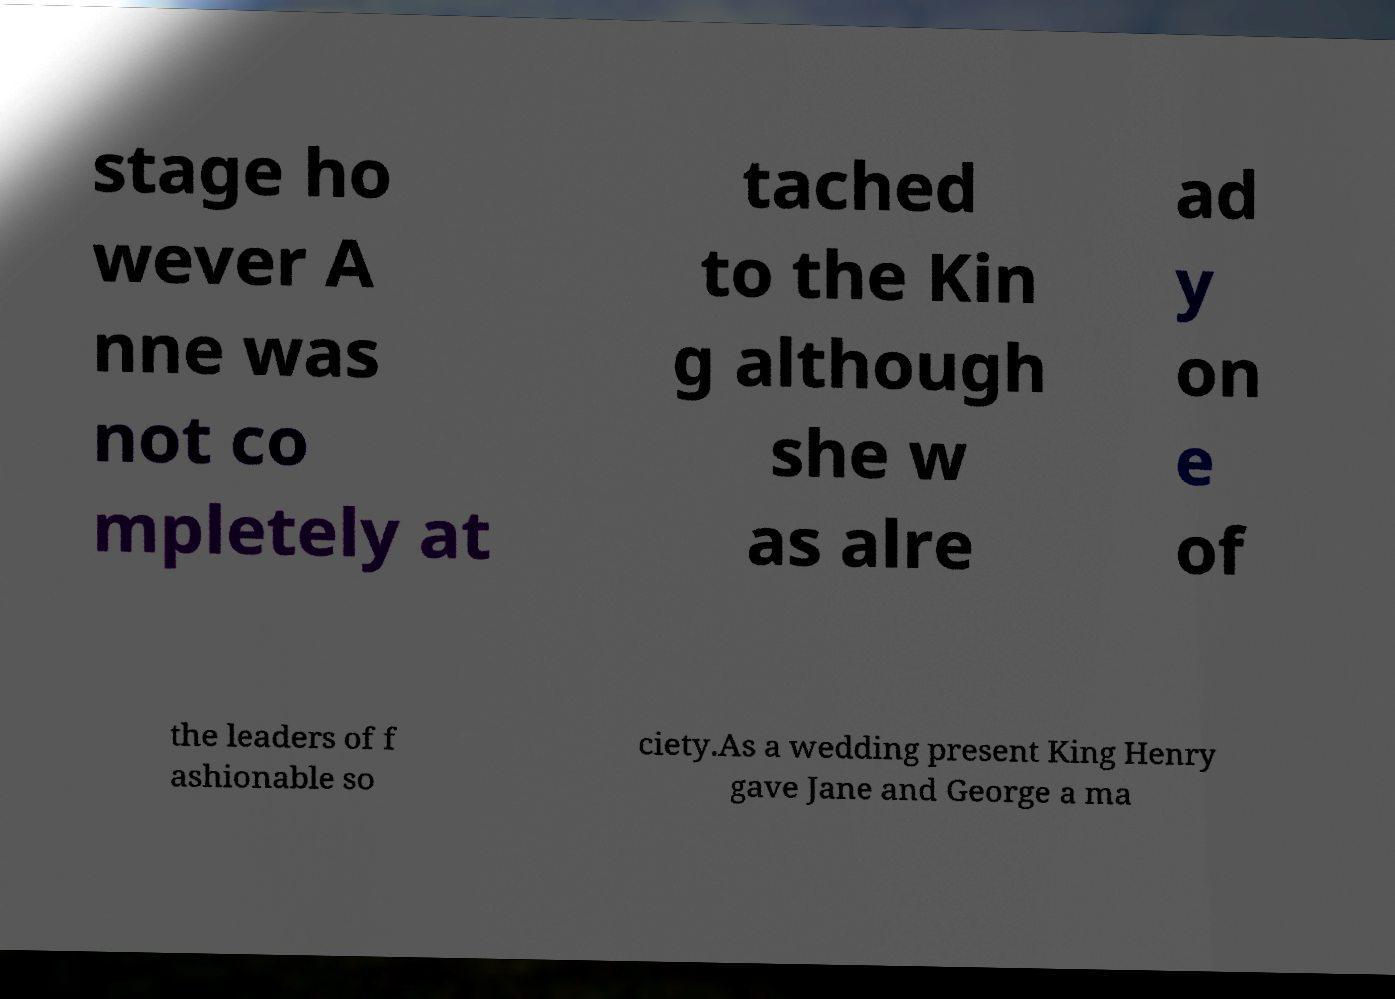Could you assist in decoding the text presented in this image and type it out clearly? stage ho wever A nne was not co mpletely at tached to the Kin g although she w as alre ad y on e of the leaders of f ashionable so ciety.As a wedding present King Henry gave Jane and George a ma 